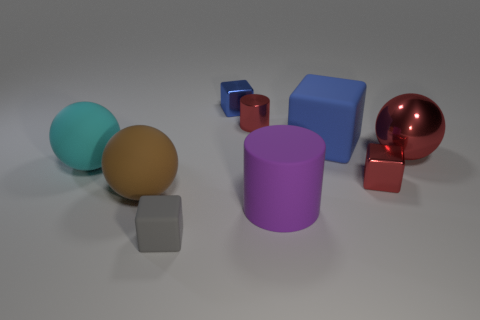Subtract all big blue cubes. How many cubes are left? 3 Add 1 tiny metal cubes. How many objects exist? 10 Subtract all cyan cylinders. How many blue blocks are left? 2 Subtract 2 spheres. How many spheres are left? 1 Subtract all purple blocks. Subtract all green balls. How many blocks are left? 4 Subtract all blue things. Subtract all blue things. How many objects are left? 5 Add 3 red cubes. How many red cubes are left? 4 Add 5 large objects. How many large objects exist? 10 Subtract all cyan spheres. How many spheres are left? 2 Subtract 1 red cubes. How many objects are left? 8 